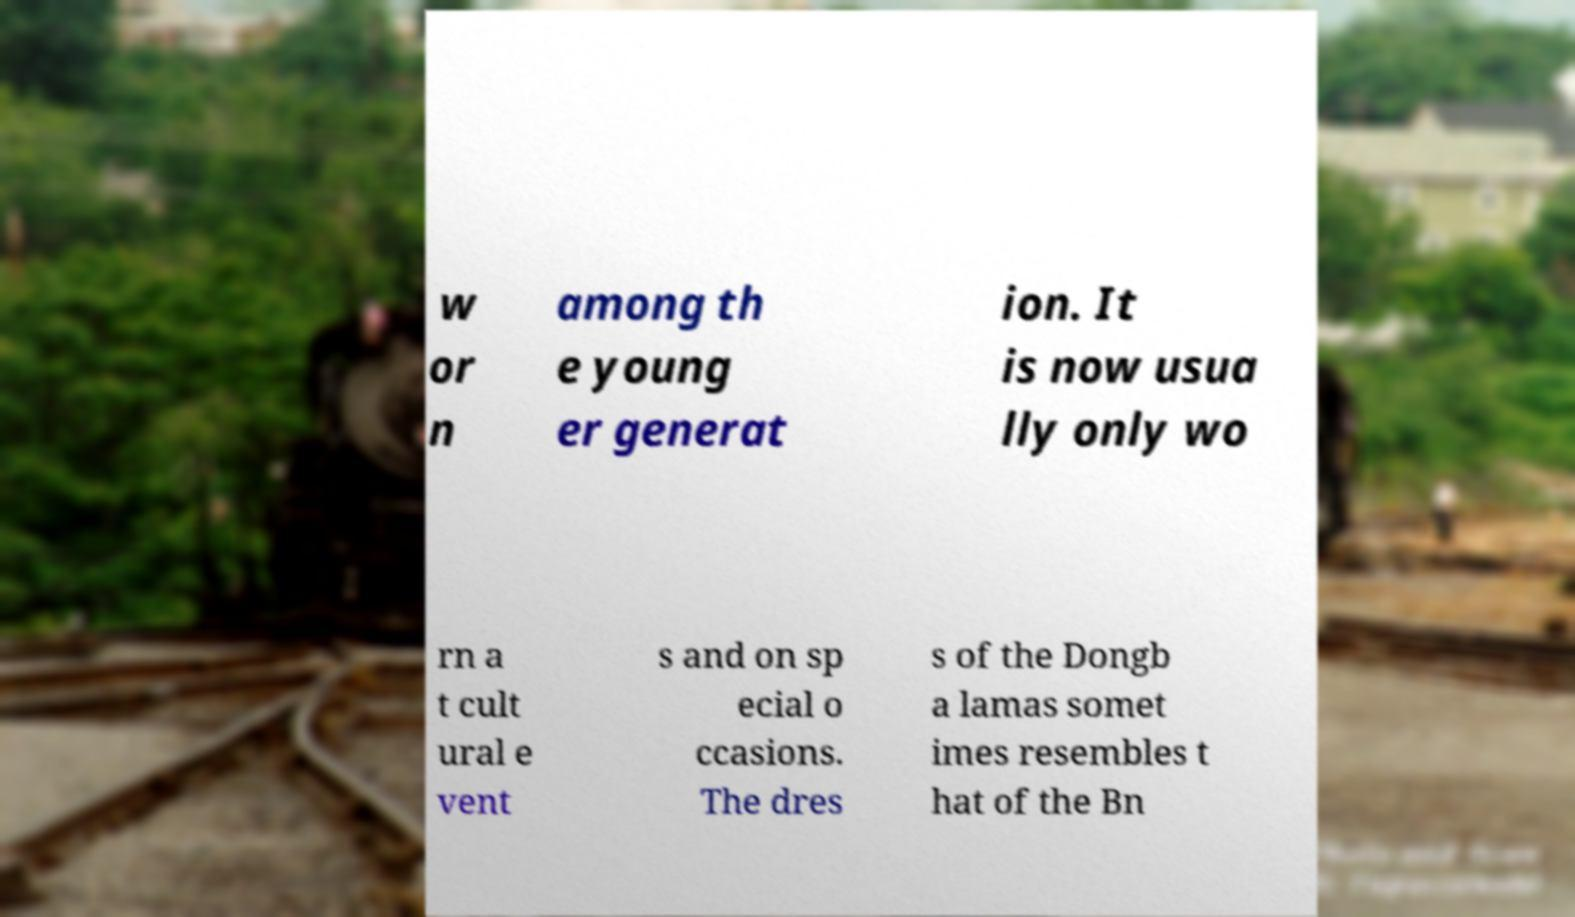Please read and relay the text visible in this image. What does it say? w or n among th e young er generat ion. It is now usua lly only wo rn a t cult ural e vent s and on sp ecial o ccasions. The dres s of the Dongb a lamas somet imes resembles t hat of the Bn 